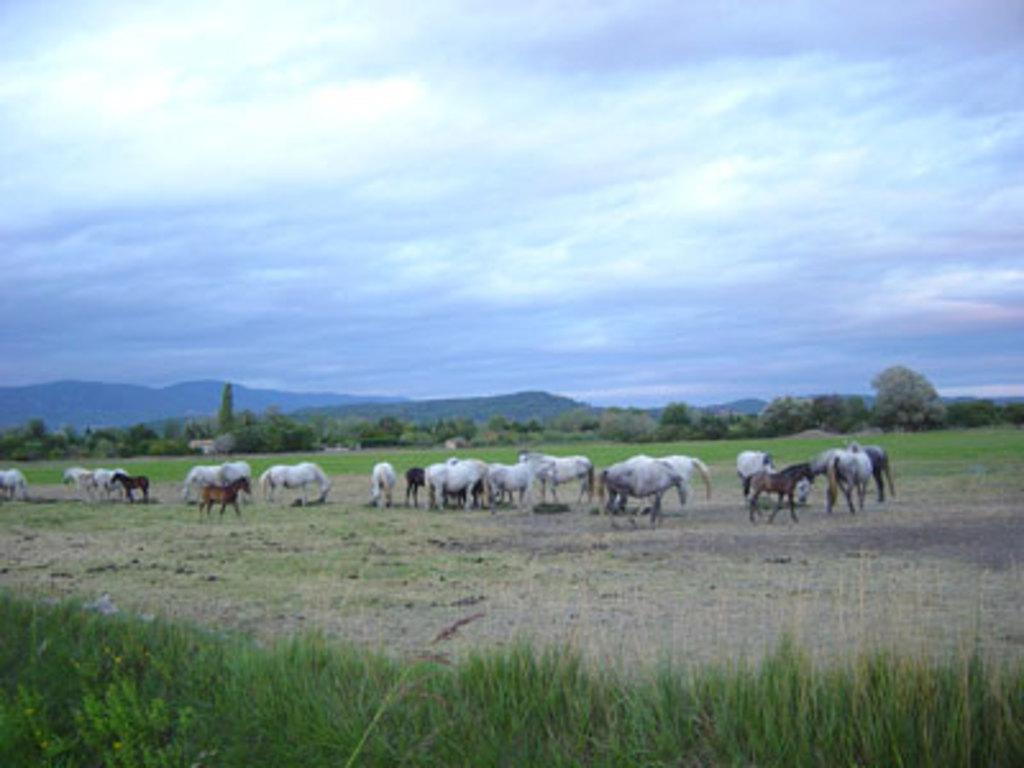Describe this image in one or two sentences. In this picture I can observe some horses from the ground. There are white and brown color horses. I can observe some grass on the bottom of the picture. In the background there are hills and some clouds in the sky. 